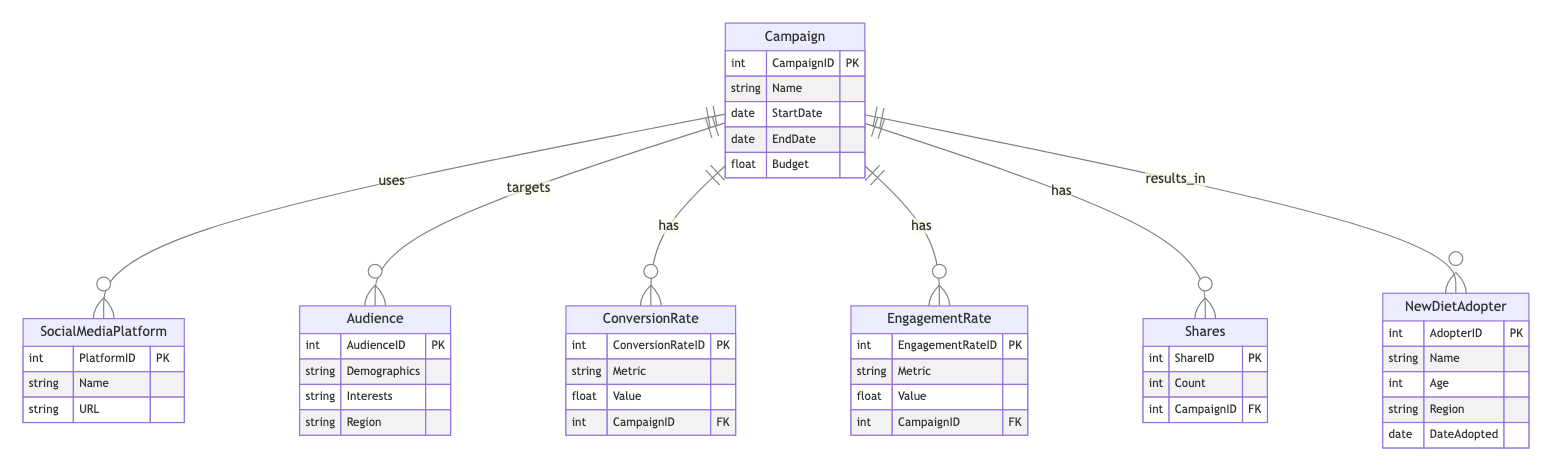What is the name of the entity that represents the audiences targeted by the campaign? The diagram shows an entity named "Audience" that includes demographic information and interests of individuals who are targeted by the campaign.
Answer: Audience How many entities are represented in the diagram? By counting the listed entities in the provided diagram code, we have a total of six distinct entities: Campaign, SocialMediaPlatform, Audience, ConversionRate, EngagementRate, Shares, and NewDietAdopter.
Answer: Six What relationship exists between Campaign and Social Media Platform? The diagram illustrates that the Campaign "uses" the Social Media Platform, indicating a connection where campaigns utilize these platforms to reach audiences.
Answer: uses What are the attributes of the New Diet Adopter entity? Based on the diagram, the attributes for the New Diet Adopter entity include AdopterID, Name, Age, Region, and DateAdopted, which collectively describe the individuals who adopt a plant-based diet.
Answer: AdopterID, Name, Age, Region, DateAdopted How does the Campaign evaluate its effectiveness in regards to New Diet Adopters? The Campaign results in New Diet Adopters, which implies that the effectiveness of the campaign can be measured based on the number of individuals who adopt a plant-based diet as a result of the outreach efforts.
Answer: results_in What type of metrics are tracked for each Campaign? The diagram indicates that Conversion Rates, Engagement Rates, and Shares are all tracked metrics related to each Campaign, helping assess different aspects of campaign performance.
Answer: Conversion Rates, Engagement Rates, Shares What is the primary relationship between the Campaign and the Audience? The primary relationship is that the Campaign "targets" the Audience, signaling that campaigns are specifically aimed at certain demographic and interest groups within the audience.
Answer: targets How is the Campaign budget represented in the diagram? The Campaign entity includes a Budget attribute, which numeric value indicates the financial resources allocated for the outreach campaign.
Answer: Budget 